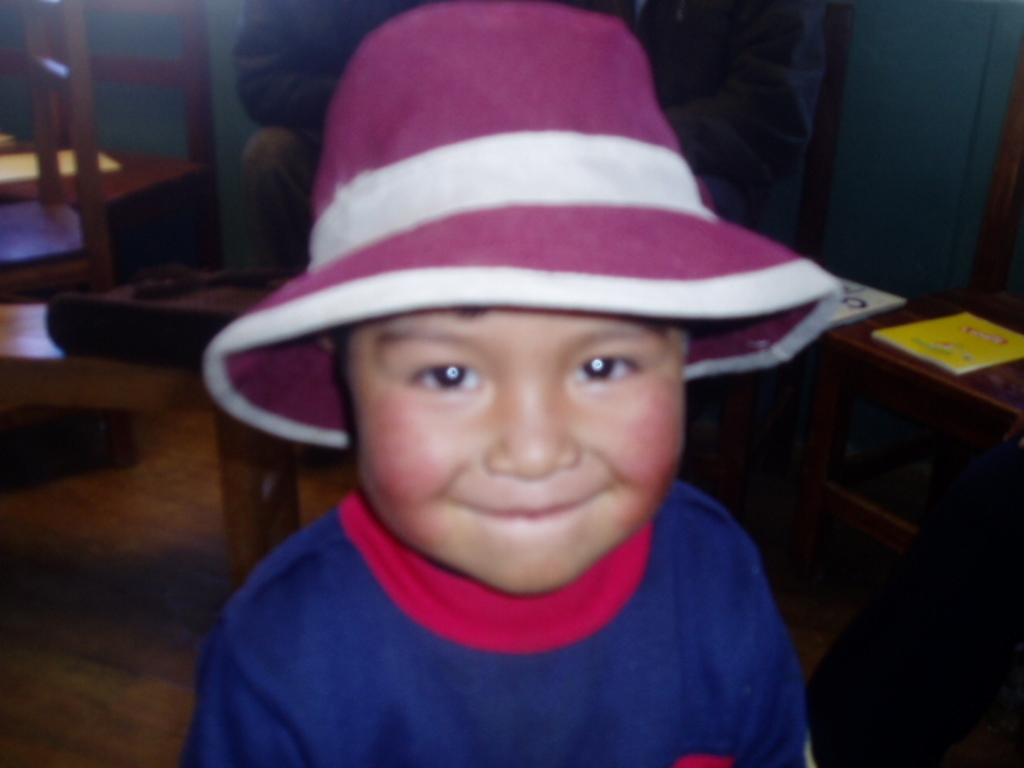What is the main subject of the image? There is a child in the image. What is the child wearing on their head? The child is wearing a hat. What object can be seen on a table in the image? There is a book on a table in the image. What type of furniture is present in the image? There are chairs in the image. What is a feature of the background in the image? There is a wall in the image. What are the people in the image doing? There are people sitting in the image. What type of beef can be seen on the hill in the image? There is no beef or hill present in the image. 